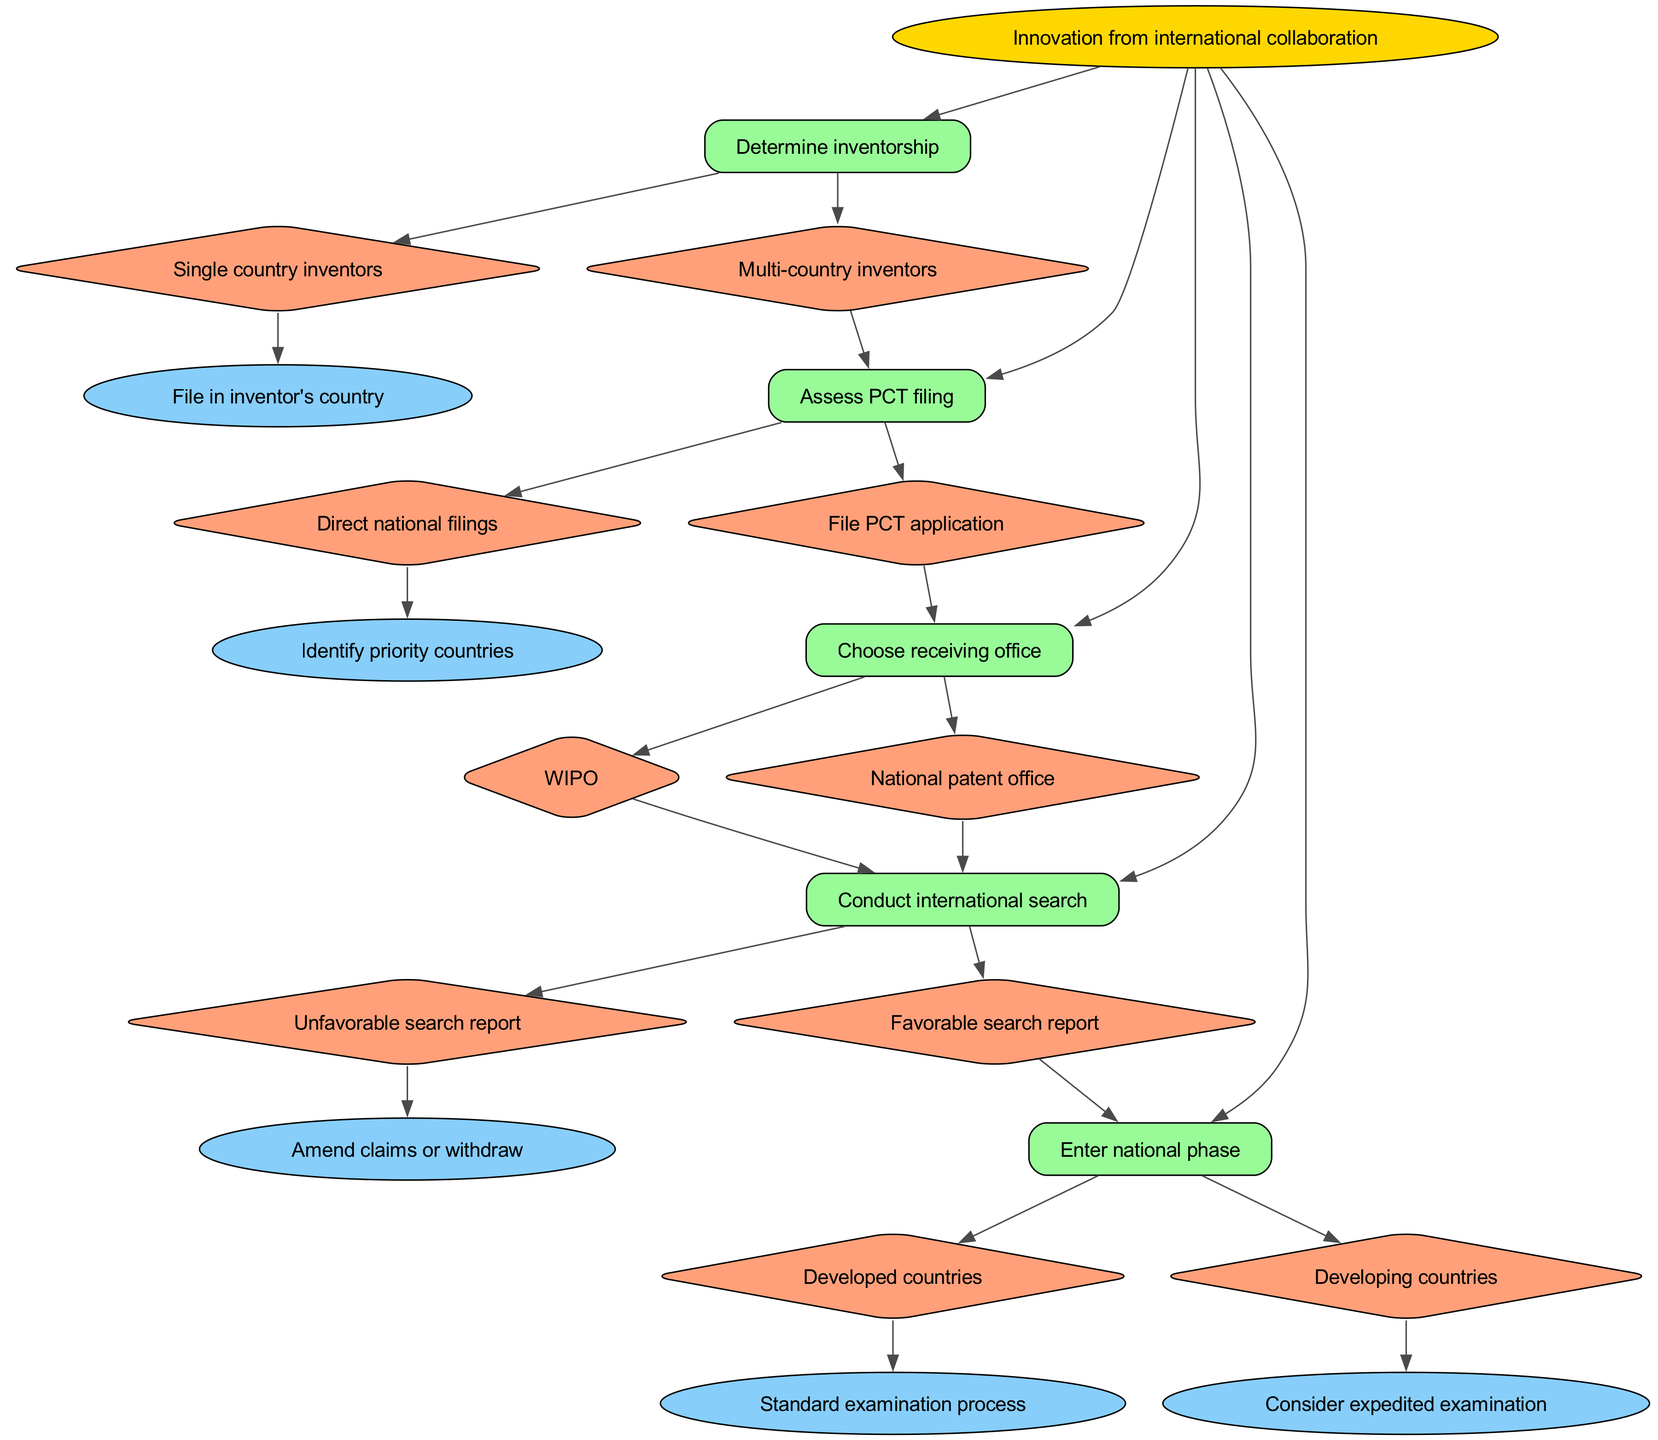What is the root node of the diagram? The root node is labeled as "Innovation from international collaboration." It represents the starting point of the decisions made in the process of patent filing related to international collaborations.
Answer: Innovation from international collaboration How many main decision nodes are present? The diagram includes four decision nodes: "Determine inventorship," "Assess PCT filing," "Choose receiving office," and "Conduct international search." Counting these gives a total of four main decision nodes.
Answer: 4 What happens after filing a PCT application? After filing a PCT application, the next step is to "Choose receiving office." This indicates that filing a PCT application leads directly to a decision about the receiving office for the application.
Answer: Choose receiving office What are the two outcomes after the international search has been conducted? After conducting an international search, the outcomes are either a "Favorable search report" leading to entering the national phase or an "Unfavorable search report" which can lead to amending claims or withdrawing the application.
Answer: Favorable search report or Unfavorable search report If the inventors are from multiple countries, what should be assessed next? If there are multi-country inventors, the next step is to "Assess PCT filing." This step focuses on determining the best method to file a patent application in relation to international collaborations.
Answer: Assess PCT filing What type of examination is considered for developing countries during the national phase? In the national phase for developing countries, it is suggested to "Consider expedited examination." This indicates a specific approach that may be taken due to varying patent application processes in these countries.
Answer: Consider expedited examination Which two offices can be chosen as the receiving office in the decision tree? The two offices that can be chosen as the receiving office are "WIPO" (World Intellectual Property Organization) and "National patent office." Both serve as possible locations for receiving the PCT application.
Answer: WIPO or National patent office What action can be taken if the search report is unfavorable? If the search report is unfavorable, the actions that can be taken are to "Amend claims or withdraw." This presents options for the applicant to either modify their claims or step back from the patent process.
Answer: Amend claims or withdraw 